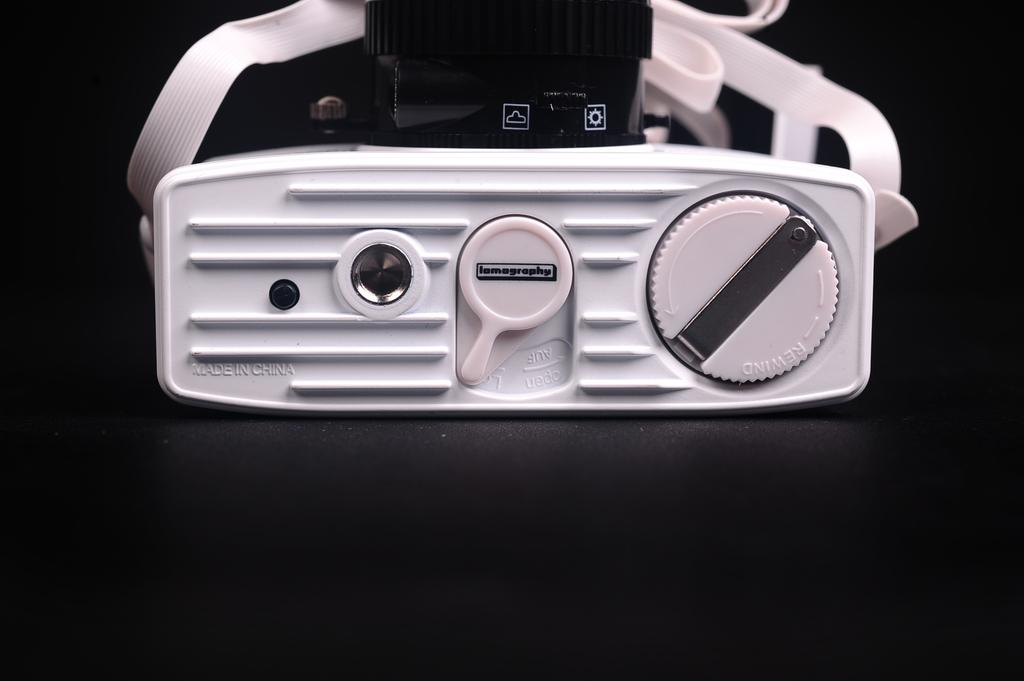What is the color of the background in the image? The background of the image is dark. What can be seen in the middle of the image? There is a projector in the middle of the image. What type of wound can be seen on the projector in the image? There is no wound present on the projector in the image. What was the cause of the aftermath visible in the image? There is no aftermath visible in the image, as it only features a projector in a dark background. 